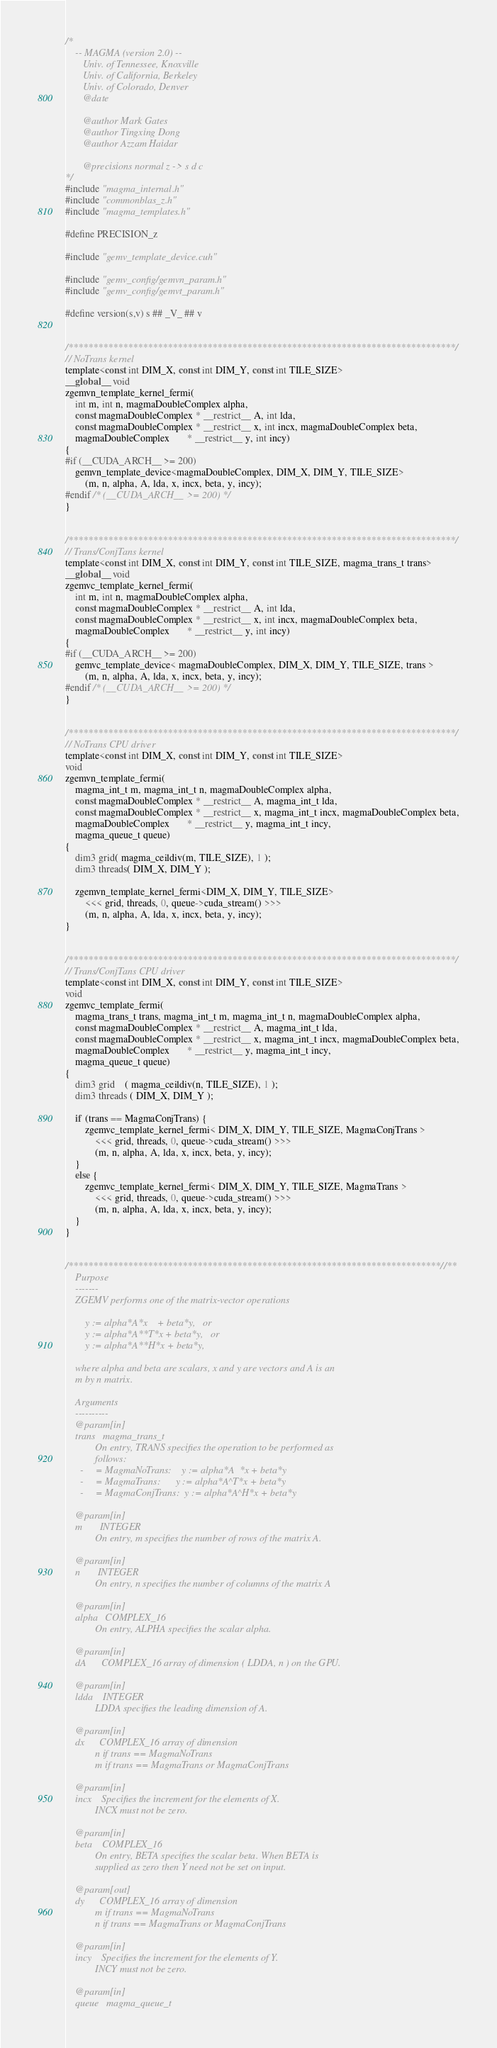Convert code to text. <code><loc_0><loc_0><loc_500><loc_500><_Cuda_>/*
    -- MAGMA (version 2.0) --
       Univ. of Tennessee, Knoxville
       Univ. of California, Berkeley
       Univ. of Colorado, Denver
       @date
       
       @author Mark Gates
       @author Tingxing Dong
       @author Azzam Haidar

       @precisions normal z -> s d c
*/
#include "magma_internal.h"
#include "commonblas_z.h"
#include "magma_templates.h"

#define PRECISION_z

#include "gemv_template_device.cuh"

#include "gemv_config/gemvn_param.h"
#include "gemv_config/gemvt_param.h"

#define version(s,v) s ## _V_ ## v


/******************************************************************************/
// NoTrans kernel
template<const int DIM_X, const int DIM_Y, const int TILE_SIZE>
__global__ void
zgemvn_template_kernel_fermi(
    int m, int n, magmaDoubleComplex alpha,
    const magmaDoubleComplex * __restrict__ A, int lda,
    const magmaDoubleComplex * __restrict__ x, int incx, magmaDoubleComplex beta,
    magmaDoubleComplex       * __restrict__ y, int incy)
{
#if (__CUDA_ARCH__ >= 200)
    gemvn_template_device<magmaDoubleComplex, DIM_X, DIM_Y, TILE_SIZE>
        (m, n, alpha, A, lda, x, incx, beta, y, incy);
#endif /* (__CUDA_ARCH__ >= 200) */
}


/******************************************************************************/
// Trans/ConjTans kernel
template<const int DIM_X, const int DIM_Y, const int TILE_SIZE, magma_trans_t trans>
__global__ void
zgemvc_template_kernel_fermi(
    int m, int n, magmaDoubleComplex alpha,
    const magmaDoubleComplex * __restrict__ A, int lda,
    const magmaDoubleComplex * __restrict__ x, int incx, magmaDoubleComplex beta,
    magmaDoubleComplex       * __restrict__ y, int incy)
{
#if (__CUDA_ARCH__ >= 200)
    gemvc_template_device< magmaDoubleComplex, DIM_X, DIM_Y, TILE_SIZE, trans >
        (m, n, alpha, A, lda, x, incx, beta, y, incy);
#endif /* (__CUDA_ARCH__ >= 200) */
}


/******************************************************************************/
// NoTrans CPU driver
template<const int DIM_X, const int DIM_Y, const int TILE_SIZE>
void
zgemvn_template_fermi(
    magma_int_t m, magma_int_t n, magmaDoubleComplex alpha,
    const magmaDoubleComplex * __restrict__ A, magma_int_t lda,
    const magmaDoubleComplex * __restrict__ x, magma_int_t incx, magmaDoubleComplex beta,
    magmaDoubleComplex       * __restrict__ y, magma_int_t incy,
    magma_queue_t queue)
{
    dim3 grid( magma_ceildiv(m, TILE_SIZE), 1 );
    dim3 threads( DIM_X, DIM_Y );

    zgemvn_template_kernel_fermi<DIM_X, DIM_Y, TILE_SIZE>
        <<< grid, threads, 0, queue->cuda_stream() >>>
        (m, n, alpha, A, lda, x, incx, beta, y, incy);
}


/******************************************************************************/
// Trans/ConjTans CPU driver
template<const int DIM_X, const int DIM_Y, const int TILE_SIZE>
void
zgemvc_template_fermi(
    magma_trans_t trans, magma_int_t m, magma_int_t n, magmaDoubleComplex alpha,
    const magmaDoubleComplex * __restrict__ A, magma_int_t lda,
    const magmaDoubleComplex * __restrict__ x, magma_int_t incx, magmaDoubleComplex beta,
    magmaDoubleComplex       * __restrict__ y, magma_int_t incy,
    magma_queue_t queue)
{
    dim3 grid    ( magma_ceildiv(n, TILE_SIZE), 1 );
    dim3 threads ( DIM_X, DIM_Y );
    
    if (trans == MagmaConjTrans) {
        zgemvc_template_kernel_fermi< DIM_X, DIM_Y, TILE_SIZE, MagmaConjTrans >
            <<< grid, threads, 0, queue->cuda_stream() >>>
            (m, n, alpha, A, lda, x, incx, beta, y, incy);
    }
    else {
        zgemvc_template_kernel_fermi< DIM_X, DIM_Y, TILE_SIZE, MagmaTrans >
            <<< grid, threads, 0, queue->cuda_stream() >>>
            (m, n, alpha, A, lda, x, incx, beta, y, incy);
    }
}


/***************************************************************************//**
    Purpose
    -------
    ZGEMV performs one of the matrix-vector operations
    
        y := alpha*A*x    + beta*y,   or
        y := alpha*A**T*x + beta*y,   or
        y := alpha*A**H*x + beta*y,
    
    where alpha and beta are scalars, x and y are vectors and A is an
    m by n matrix.

    Arguments
    ----------
    @param[in]
    trans   magma_trans_t
            On entry, TRANS specifies the operation to be performed as
            follows:
      -     = MagmaNoTrans:    y := alpha*A  *x + beta*y
      -     = MagmaTrans:      y := alpha*A^T*x + beta*y
      -     = MagmaConjTrans:  y := alpha*A^H*x + beta*y

    @param[in]
    m       INTEGER
            On entry, m specifies the number of rows of the matrix A.

    @param[in]
    n       INTEGER
            On entry, n specifies the number of columns of the matrix A
 
    @param[in]
    alpha   COMPLEX_16
            On entry, ALPHA specifies the scalar alpha.

    @param[in]
    dA      COMPLEX_16 array of dimension ( LDDA, n ) on the GPU.
   
    @param[in]
    ldda    INTEGER
            LDDA specifies the leading dimension of A.

    @param[in]
    dx      COMPLEX_16 array of dimension
            n if trans == MagmaNoTrans
            m if trans == MagmaTrans or MagmaConjTrans
     
    @param[in]
    incx    Specifies the increment for the elements of X.
            INCX must not be zero.
  
    @param[in]
    beta    COMPLEX_16
            On entry, BETA specifies the scalar beta. When BETA is
            supplied as zero then Y need not be set on input.

    @param[out]
    dy      COMPLEX_16 array of dimension
            m if trans == MagmaNoTrans
            n if trans == MagmaTrans or MagmaConjTrans

    @param[in]
    incy    Specifies the increment for the elements of Y.
            INCY must not be zero.

    @param[in]
    queue   magma_queue_t</code> 